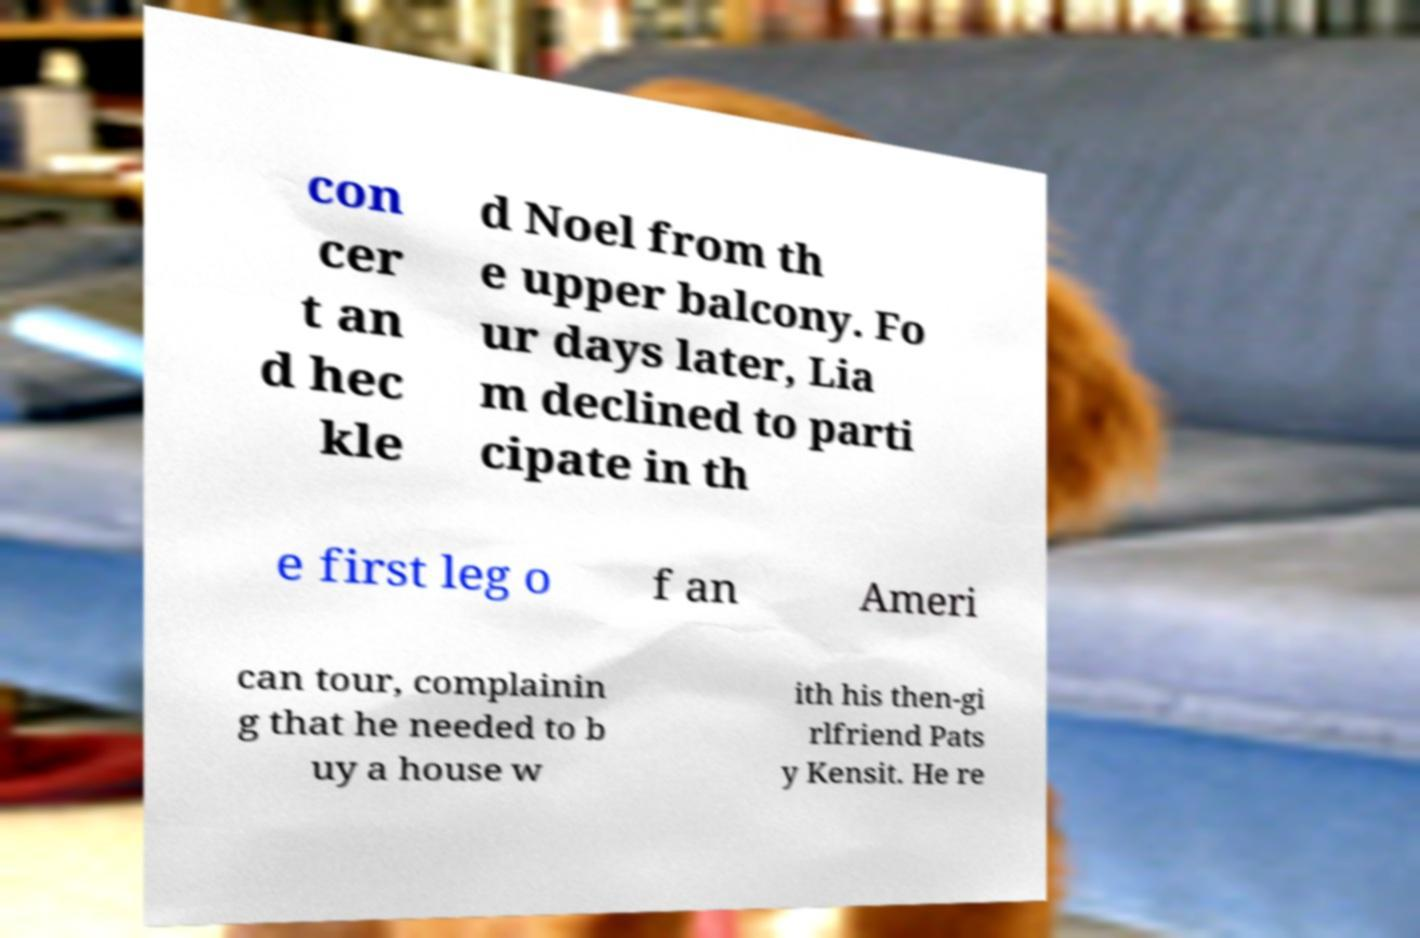Can you accurately transcribe the text from the provided image for me? con cer t an d hec kle d Noel from th e upper balcony. Fo ur days later, Lia m declined to parti cipate in th e first leg o f an Ameri can tour, complainin g that he needed to b uy a house w ith his then-gi rlfriend Pats y Kensit. He re 